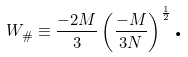Convert formula to latex. <formula><loc_0><loc_0><loc_500><loc_500>W _ { \# } \equiv \frac { - 2 M } { 3 } \left ( \frac { - M } { 3 N } \right ) ^ { \frac { 1 } { 2 } } \text {.}</formula> 